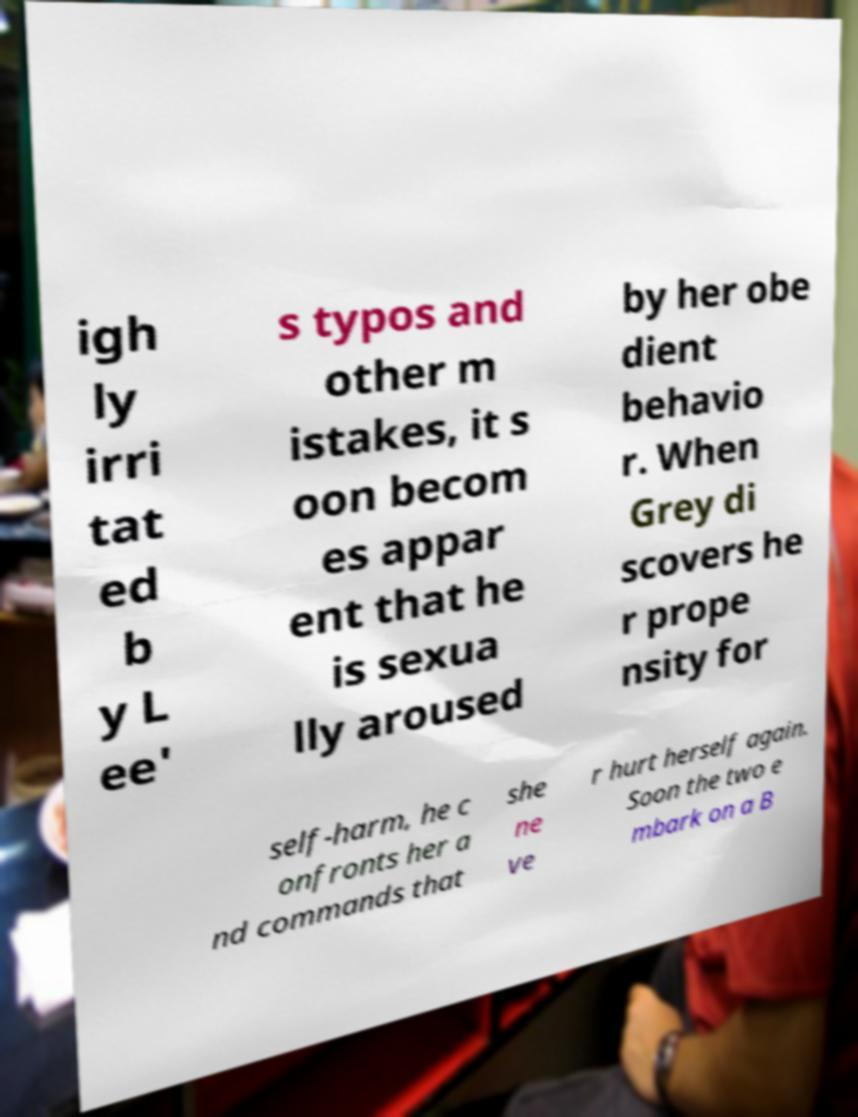What messages or text are displayed in this image? I need them in a readable, typed format. igh ly irri tat ed b y L ee' s typos and other m istakes, it s oon becom es appar ent that he is sexua lly aroused by her obe dient behavio r. When Grey di scovers he r prope nsity for self-harm, he c onfronts her a nd commands that she ne ve r hurt herself again. Soon the two e mbark on a B 